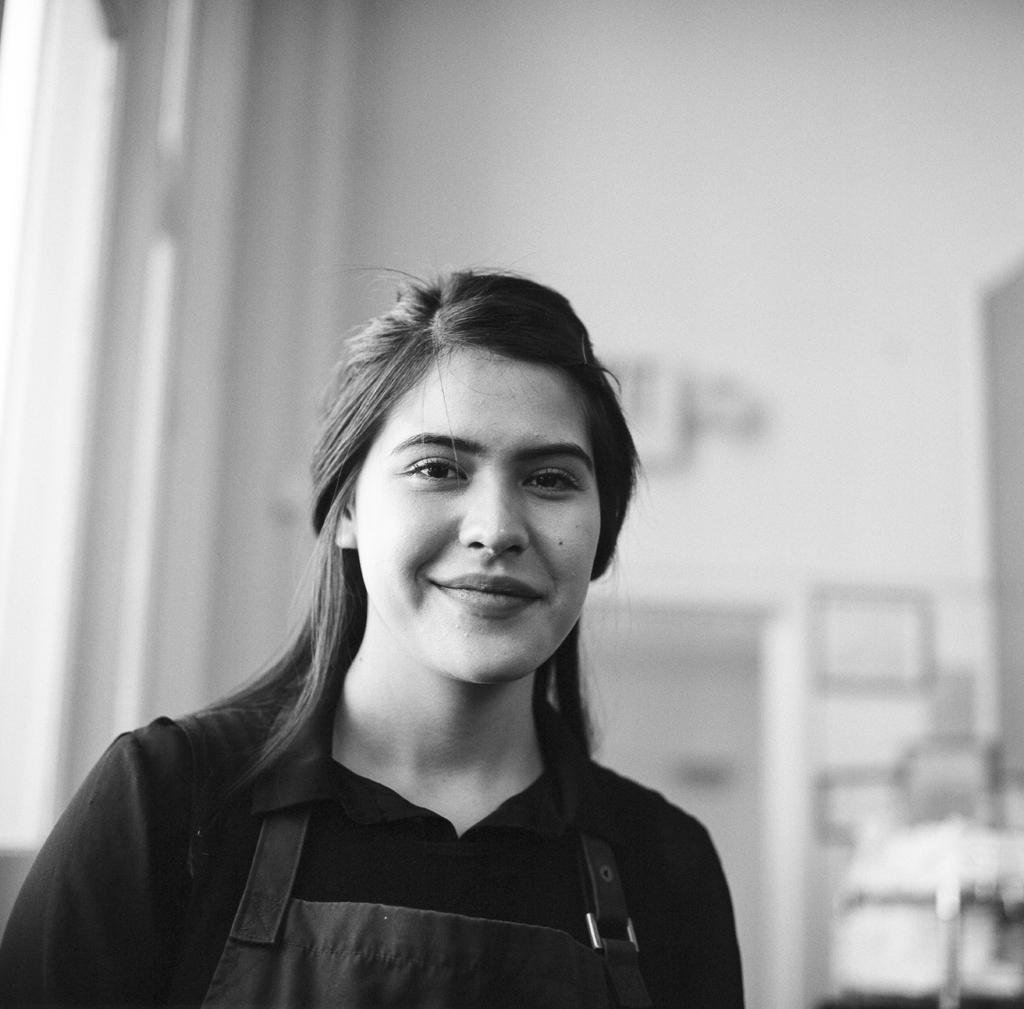What is the color scheme of the image? The picture is black and white. Can you describe the background of the image? The background of the image is blurred. What can be seen in the foreground of the image? There is a wall visible in the image. What else is present in the image besides the wall? There are objects and a woman in the image. How is the woman depicted in the image? The woman is present in the image and is smiling. What type of ticket is the woman holding in the image? There is no ticket present in the image; the woman is not holding anything. What is the name of the woman in the image? The name of the woman is not mentioned or visible in the image. 